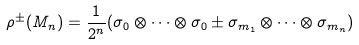Convert formula to latex. <formula><loc_0><loc_0><loc_500><loc_500>\rho ^ { \pm } ( M _ { n } ) = \frac { 1 } { 2 ^ { n } } ( \sigma _ { 0 } \otimes \cdots \otimes \sigma _ { 0 } \pm \sigma _ { { m } _ { 1 } } \otimes \cdots \otimes \sigma _ { { m } _ { n } } )</formula> 